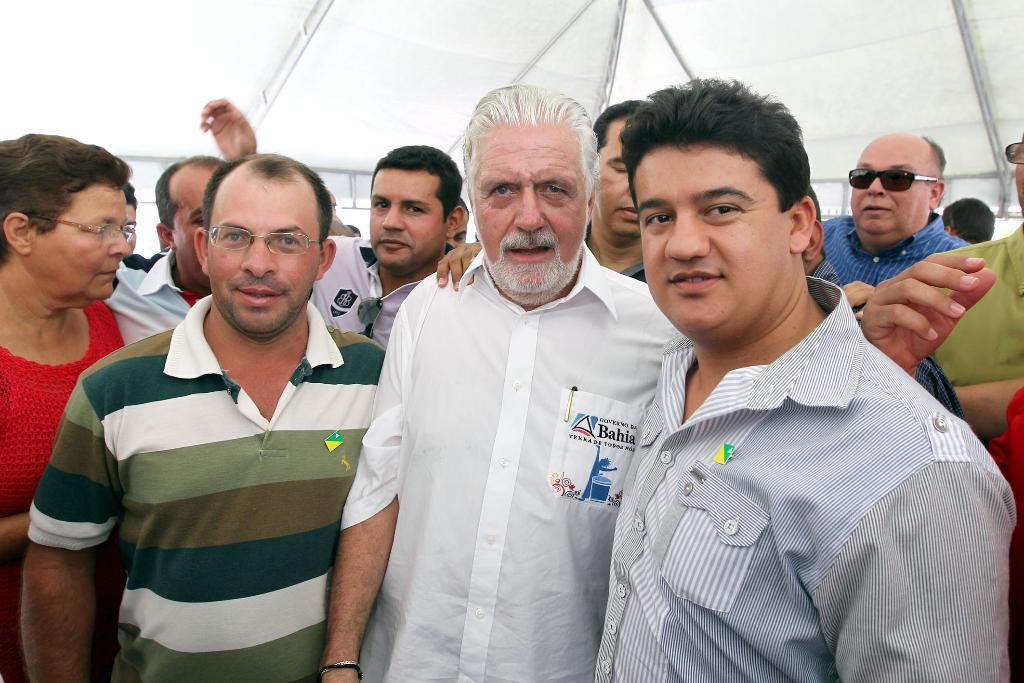What is happening in the image? There are people standing in the image. Can you describe any structures or objects in the image? Yes, there is a tent visible at the top of the image. What type of picture is hanging on the wall in the image? There is no mention of a picture hanging on the wall in the image, as the facts only mention people standing and a tent. 